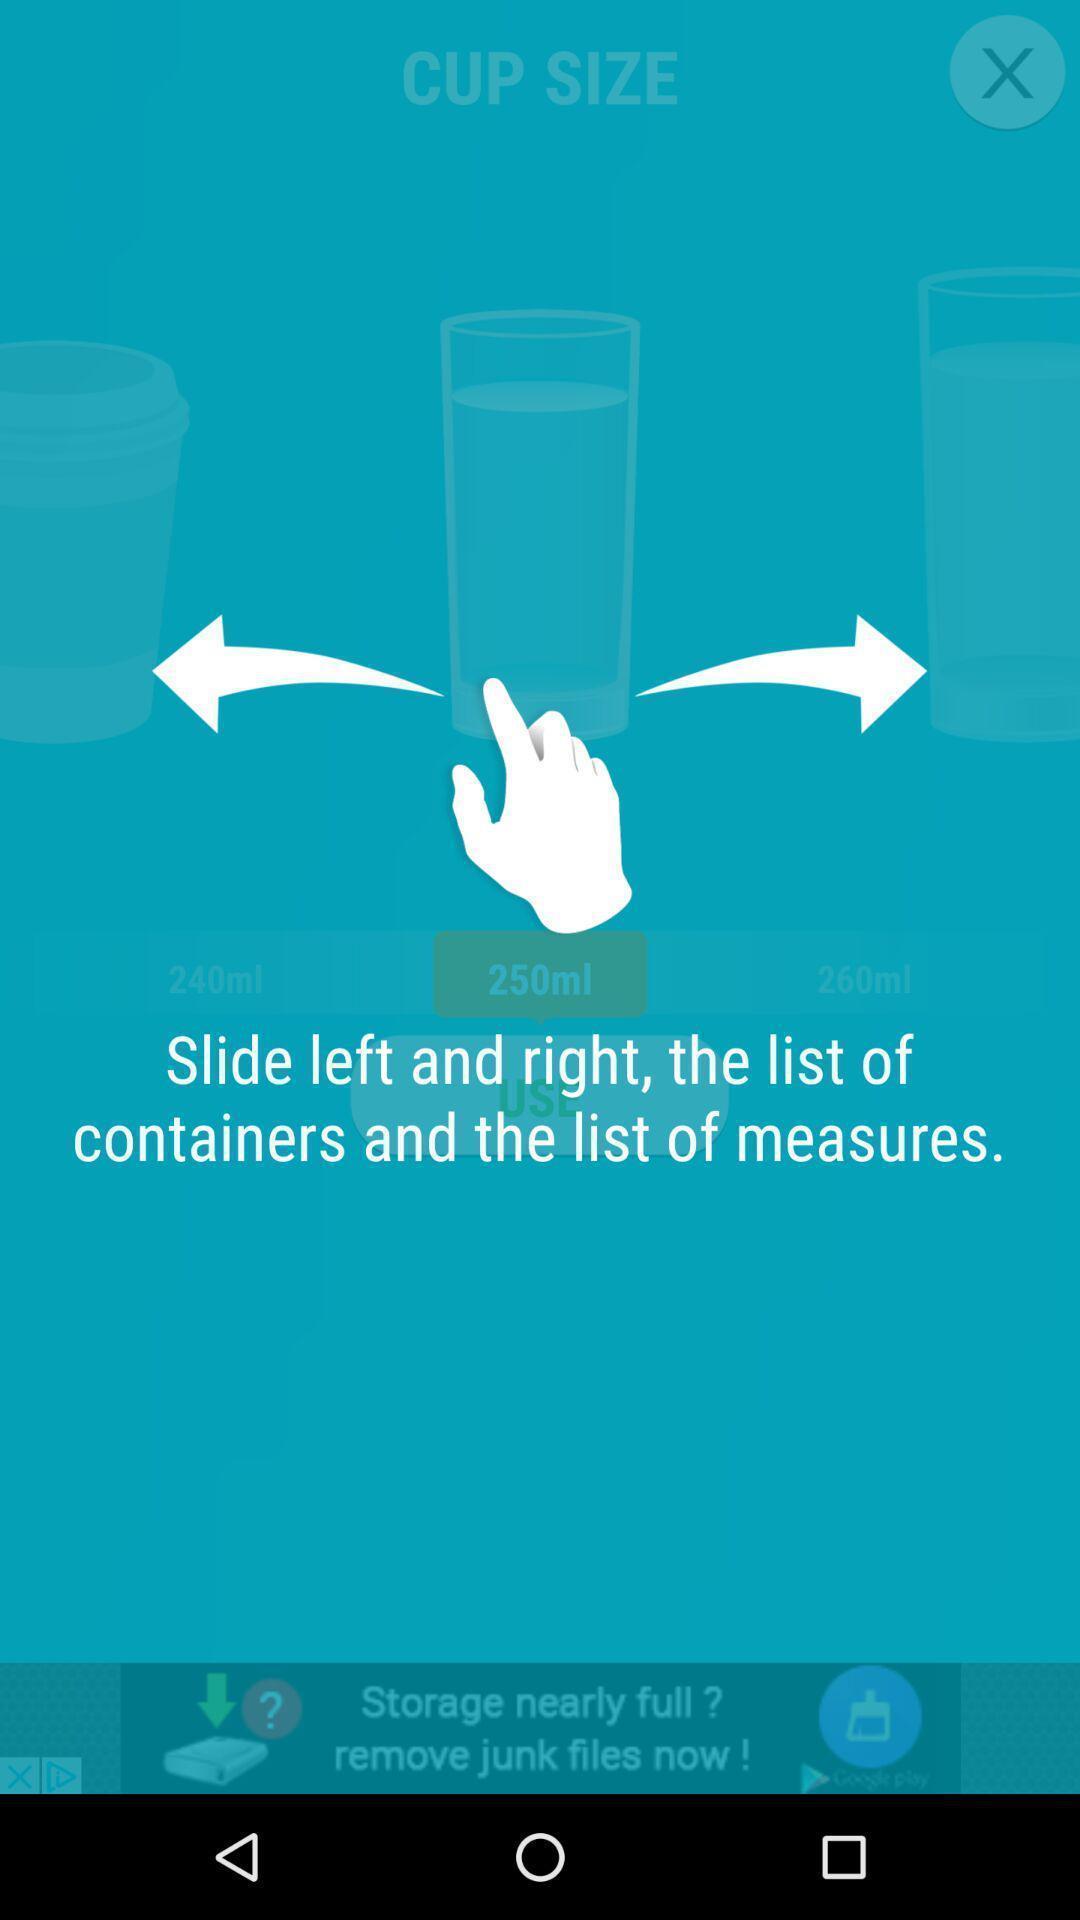Give me a summary of this screen capture. To find cup size slide left and right. 